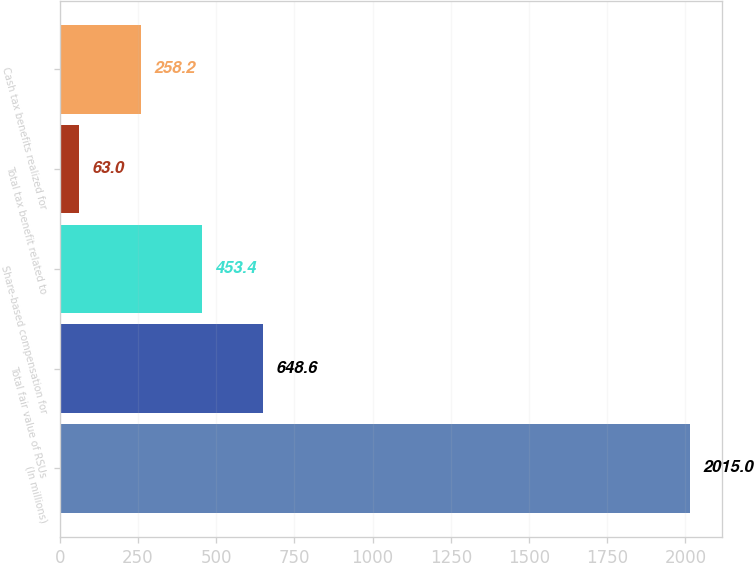Convert chart. <chart><loc_0><loc_0><loc_500><loc_500><bar_chart><fcel>(In millions)<fcel>Total fair value of RSUs<fcel>Share-based compensation for<fcel>Total tax benefit related to<fcel>Cash tax benefits realized for<nl><fcel>2015<fcel>648.6<fcel>453.4<fcel>63<fcel>258.2<nl></chart> 